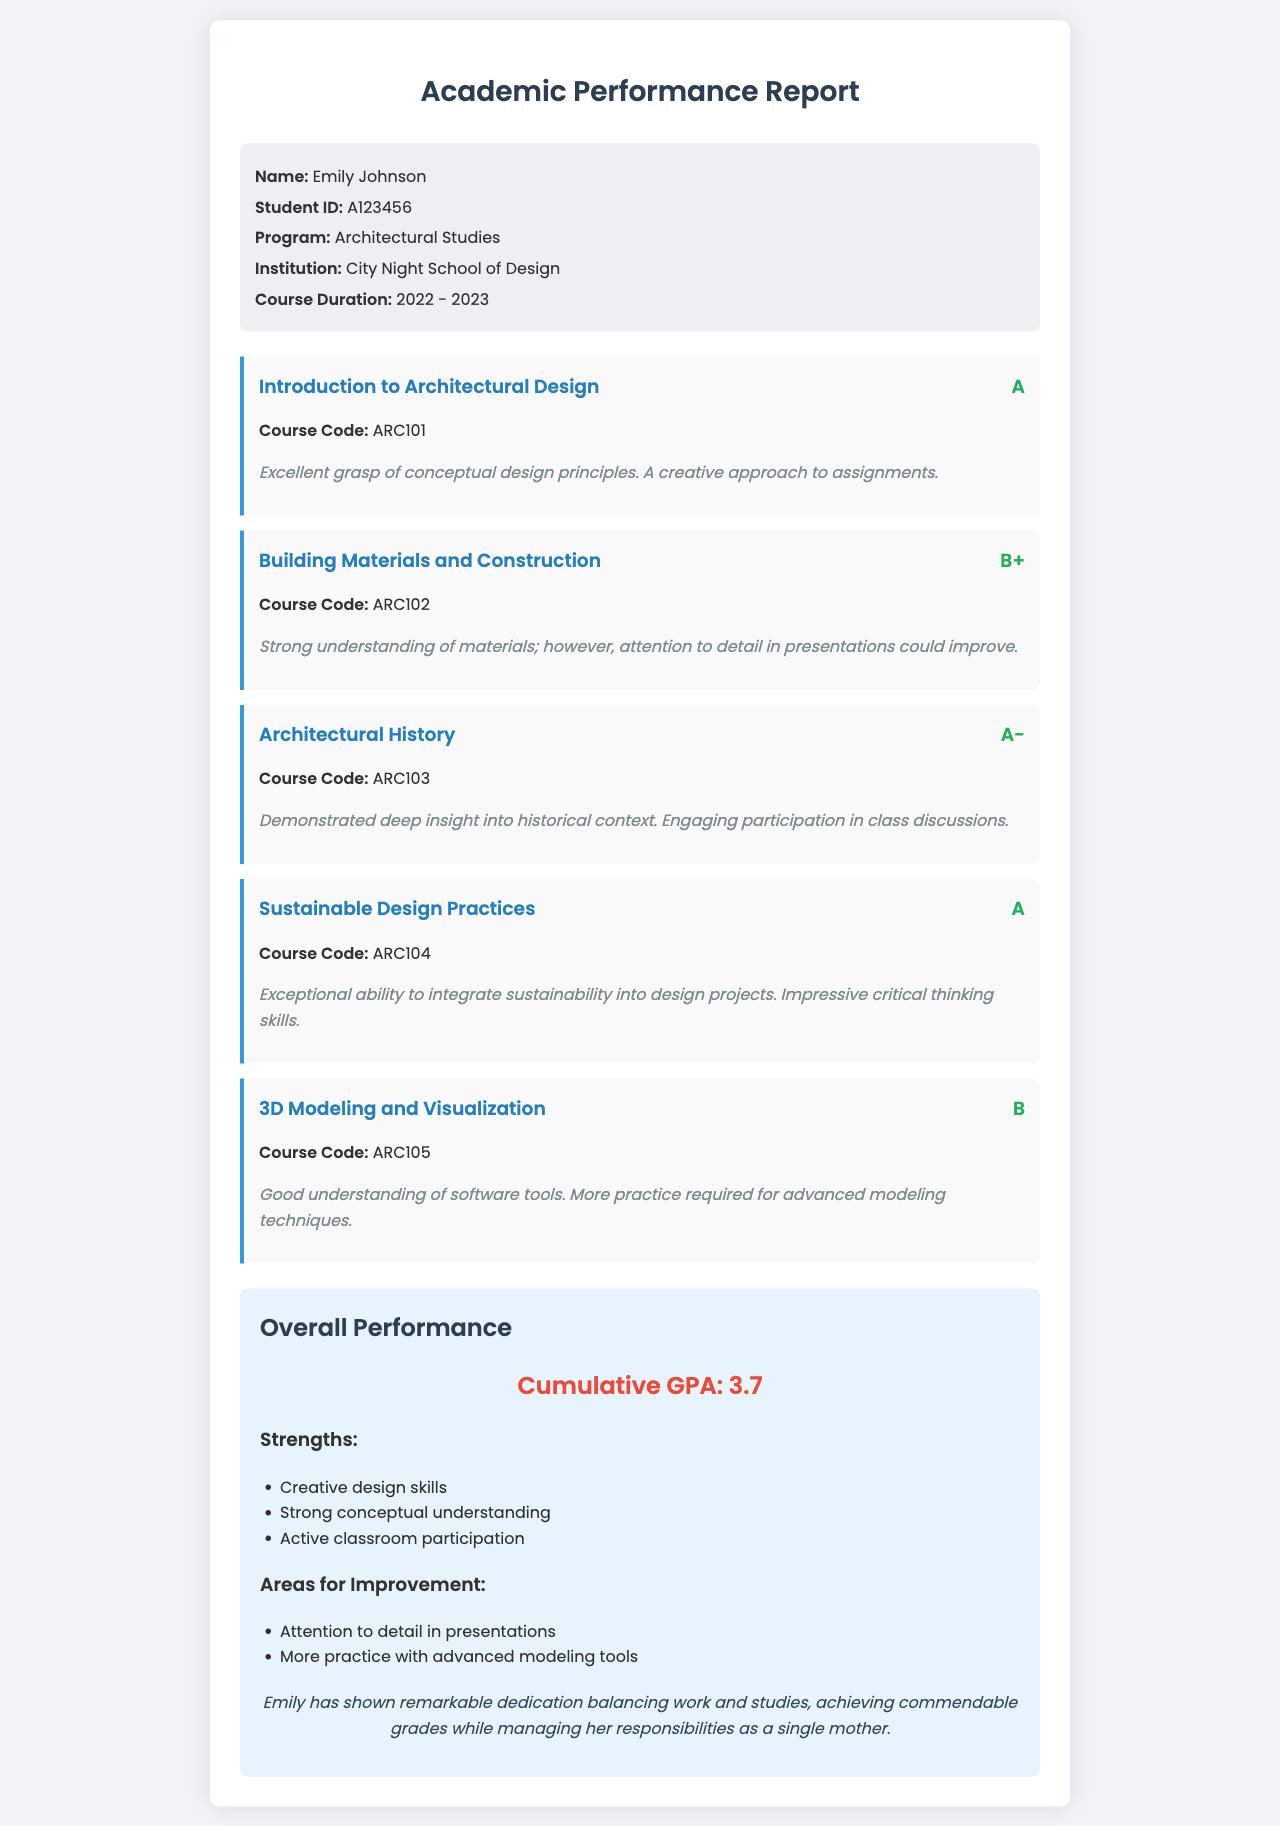What is the student ID? The student ID is a unique identifier for Emily Johnson in the document, which is A123456.
Answer: A123456 What is Emily's cumulative GPA? The cumulative GPA is a measure of all grades from courses, which is stated as 3.7 in the document.
Answer: 3.7 Which course received an A grade? The document lists the grades for various courses, and "Introduction to Architectural Design" and "Sustainable Design Practices" both received an A.
Answer: Introduction to Architectural Design, Sustainable Design Practices What is one area for improvement mentioned? The document specifies areas for improvement, one of which is attention to detail in presentations.
Answer: Attention to detail in presentations What institution did Emily attend? The institution where Emily studied is mentioned in the document as City Night School of Design.
Answer: City Night School of Design What feedback was given for the course "3D Modeling and Visualization"? The feedback is a specific comment about the course, stating that more practice is required for advanced modeling techniques.
Answer: More practice required for advanced modeling techniques What year did the course duration start? The course duration is mentioned in the document and states it started in 2022.
Answer: 2022 Name one of Emily's strengths identified in the report. The report lists strengths, one of which is her creative design skills.
Answer: Creative design skills 